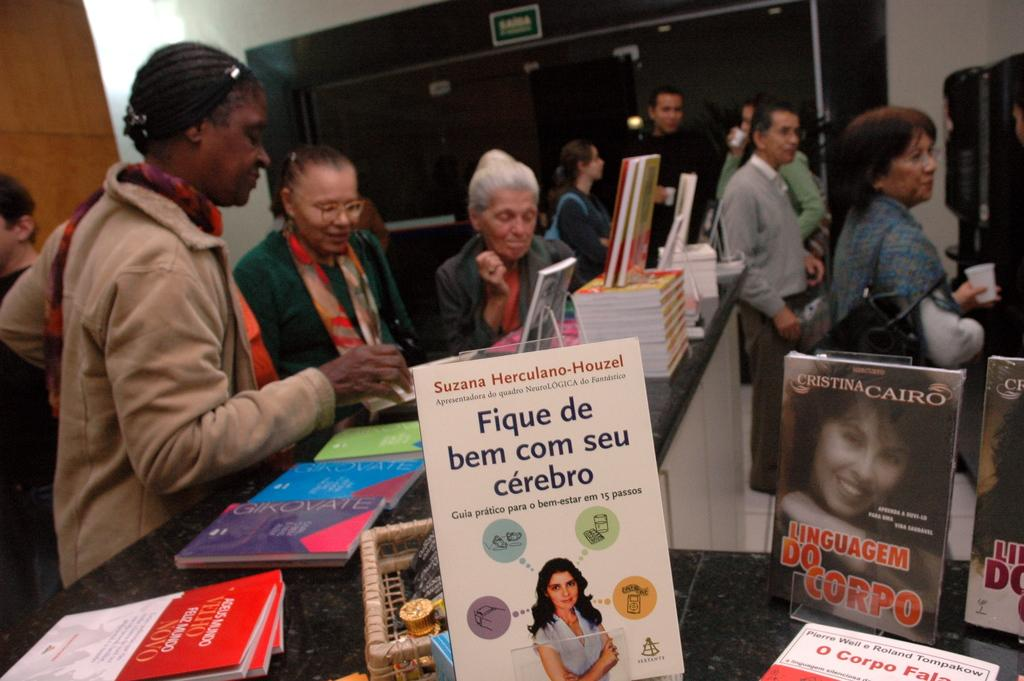<image>
Render a clear and concise summary of the photo. People looking at multiple spanish language books on display with the one prominent one being titled Fique de bem corn seu cerbro. 